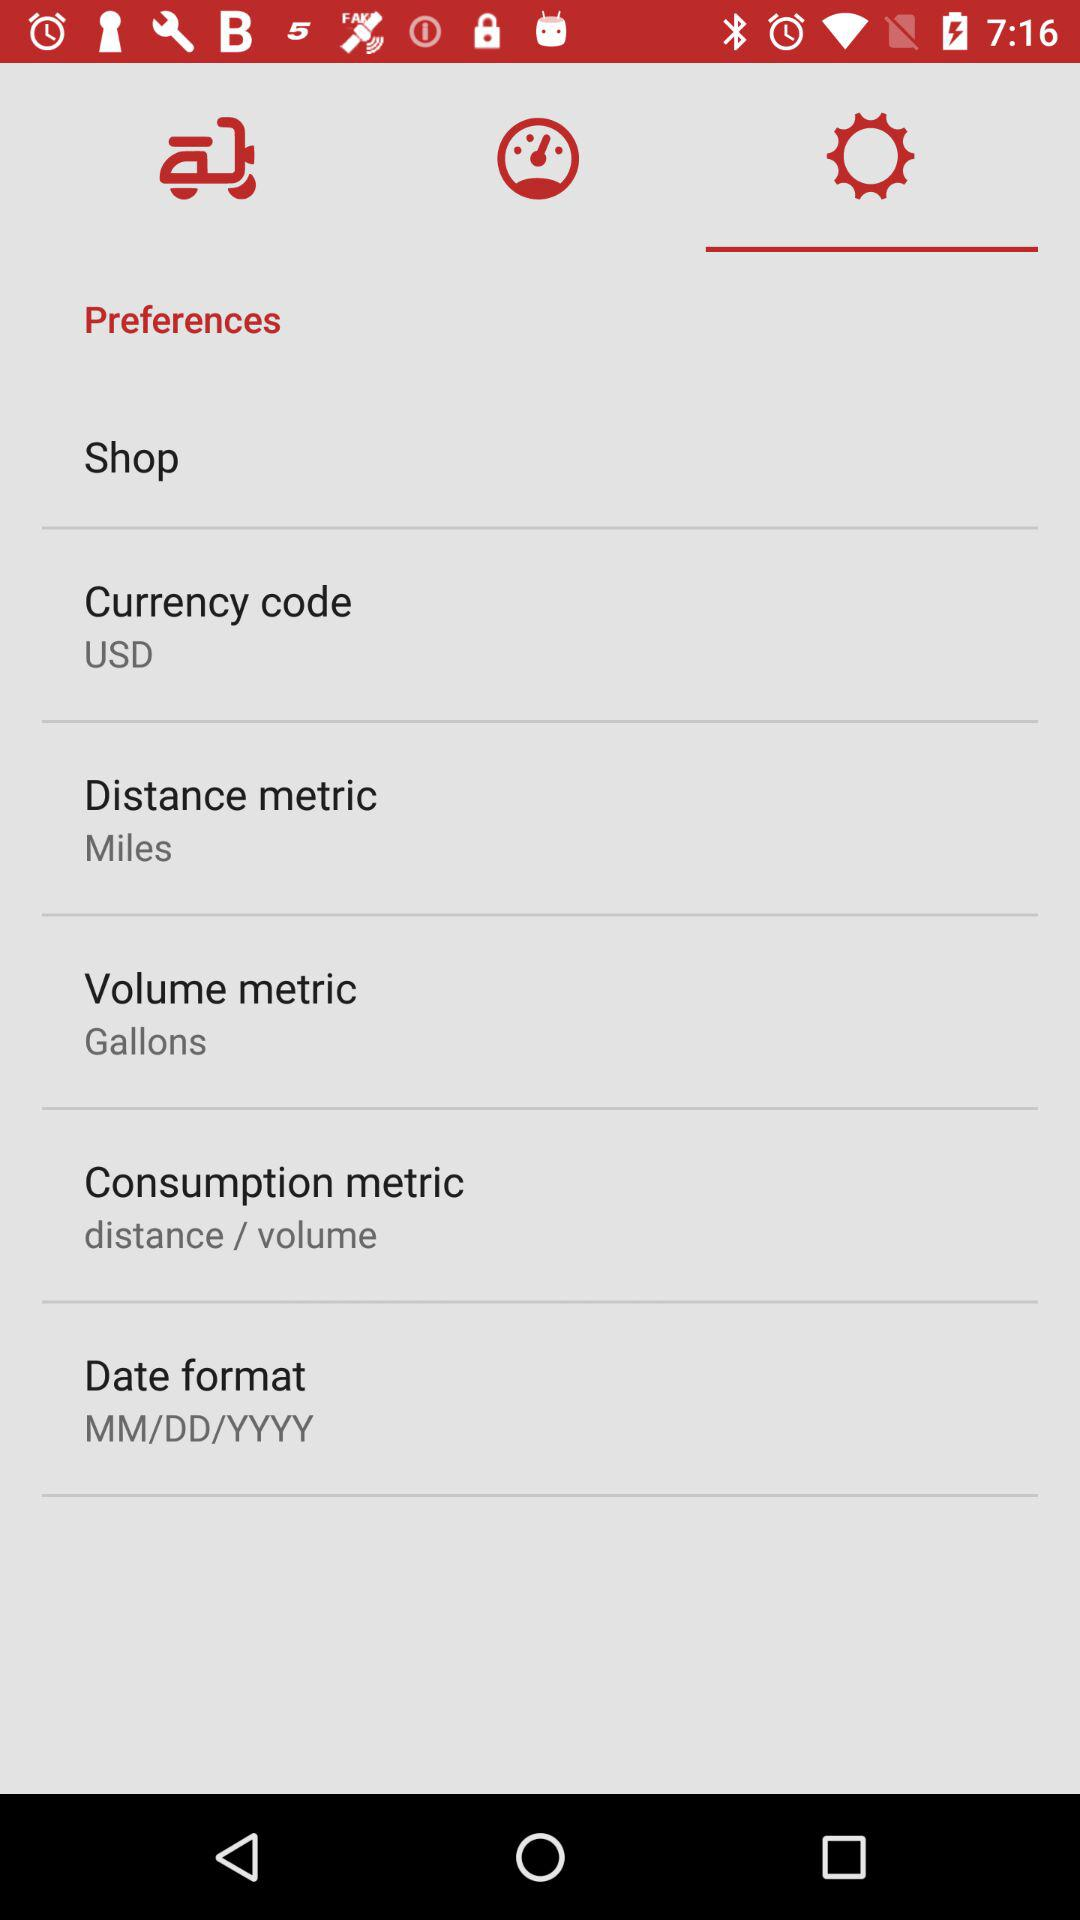What is the currency code? The currency code is USD. 